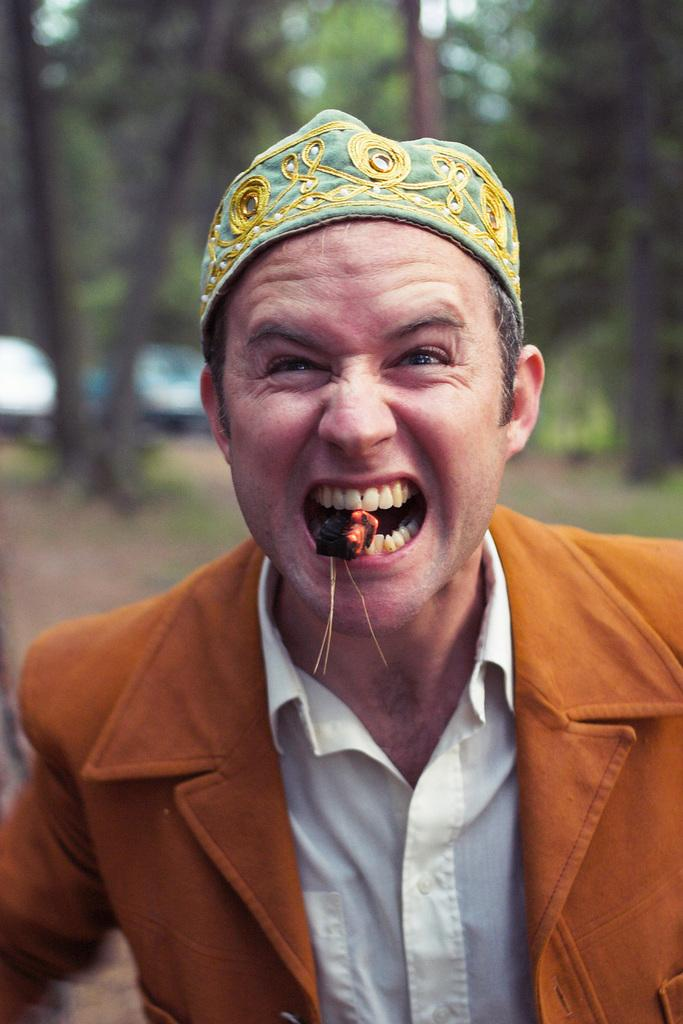What is the main subject of the image? There is a man in the image. What is the man doing in the image? The man is holding an object with his teeth. What is the man wearing in the image? The man is wearing a suit. Can you describe the background of the image? The background of the image is blurred, but there is greenery visible. What type of eggnog is being transported by the man in the image? There is no eggnog present in the image, and the man is not shown transporting anything. 